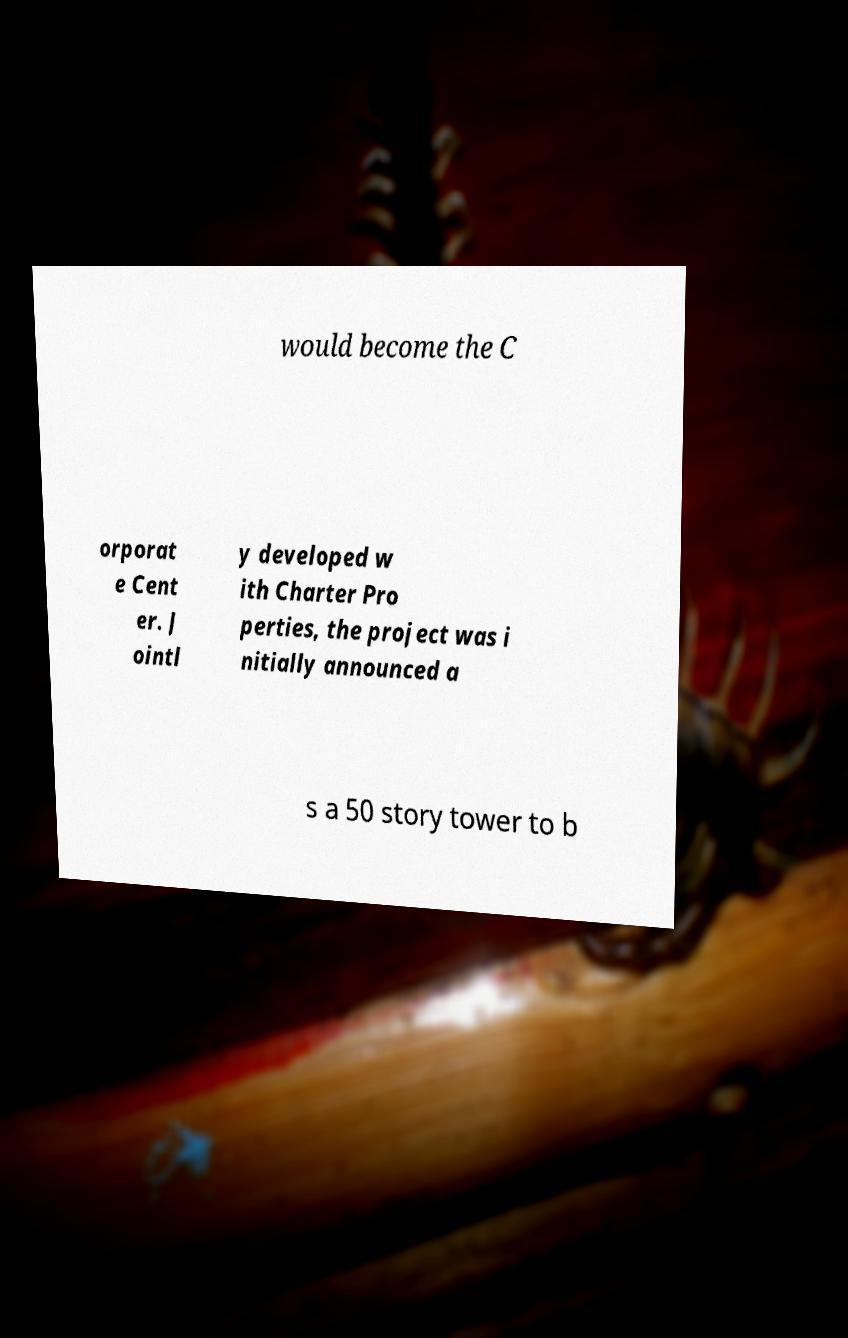Could you assist in decoding the text presented in this image and type it out clearly? would become the C orporat e Cent er. J ointl y developed w ith Charter Pro perties, the project was i nitially announced a s a 50 story tower to b 